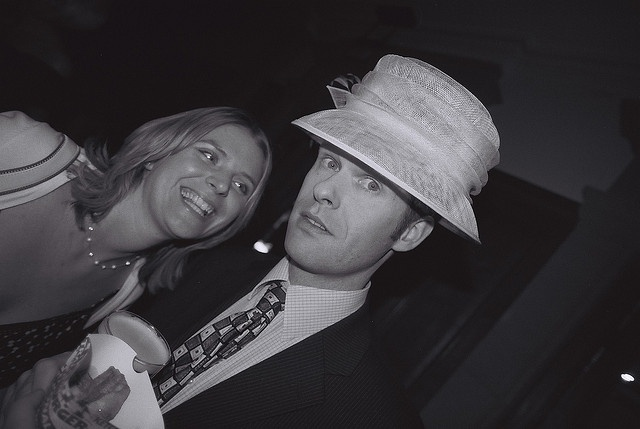Describe the objects in this image and their specific colors. I can see people in black, darkgray, gray, and lightgray tones, people in black and gray tones, tie in black, gray, and darkgray tones, and cup in black and gray tones in this image. 